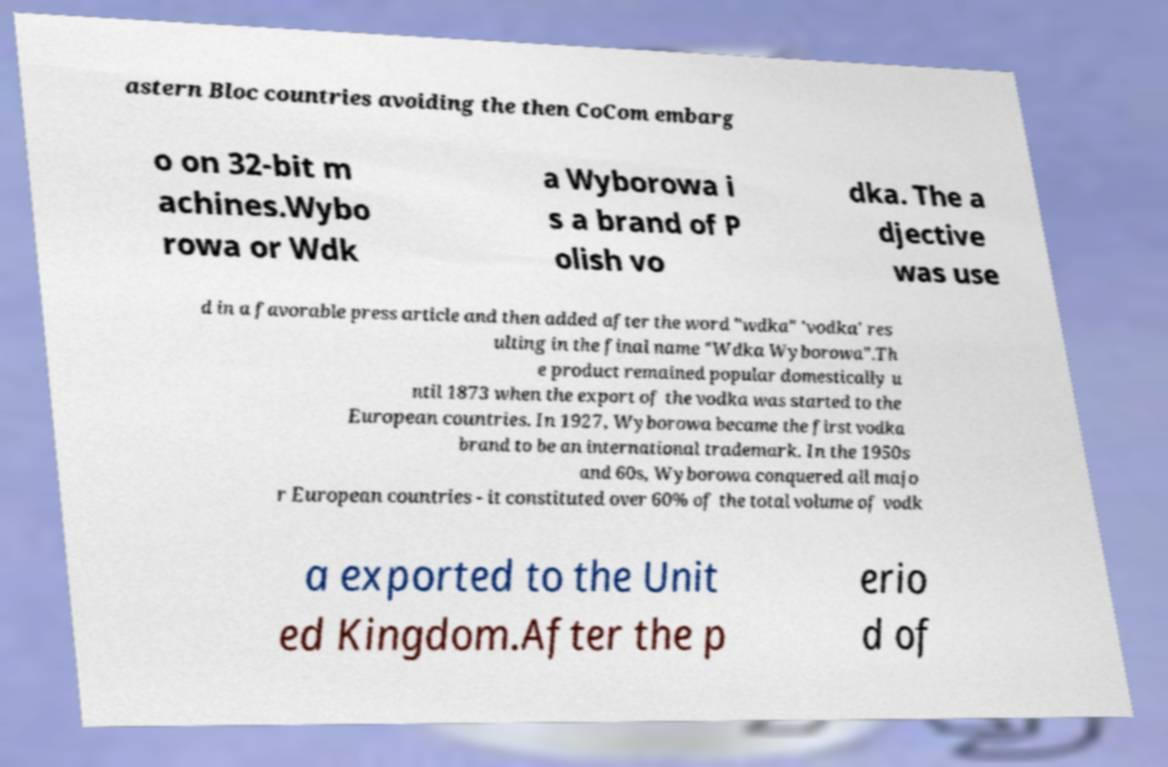What messages or text are displayed in this image? I need them in a readable, typed format. astern Bloc countries avoiding the then CoCom embarg o on 32-bit m achines.Wybo rowa or Wdk a Wyborowa i s a brand of P olish vo dka. The a djective was use d in a favorable press article and then added after the word "wdka" 'vodka' res ulting in the final name "Wdka Wyborowa".Th e product remained popular domestically u ntil 1873 when the export of the vodka was started to the European countries. In 1927, Wyborowa became the first vodka brand to be an international trademark. In the 1950s and 60s, Wyborowa conquered all majo r European countries - it constituted over 60% of the total volume of vodk a exported to the Unit ed Kingdom.After the p erio d of 